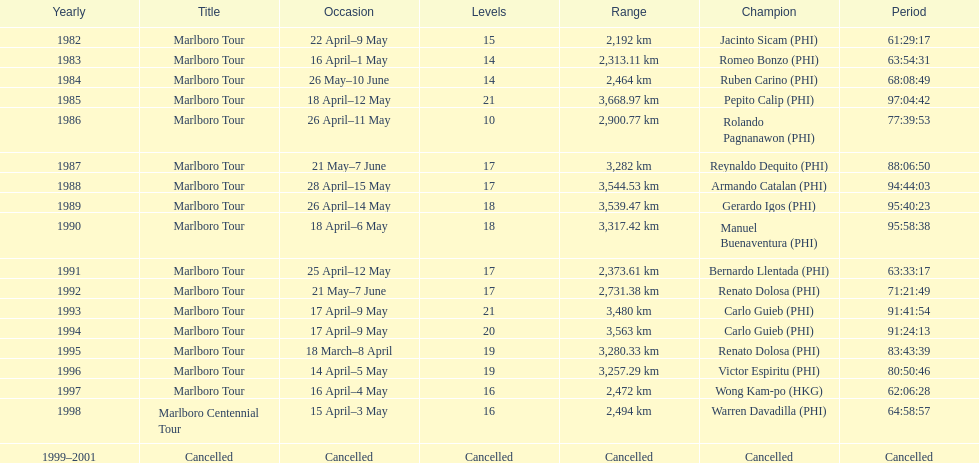Who was the only winner to have their time below 61:45:00? Jacinto Sicam. 